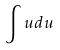Convert formula to latex. <formula><loc_0><loc_0><loc_500><loc_500>\int u d u</formula> 